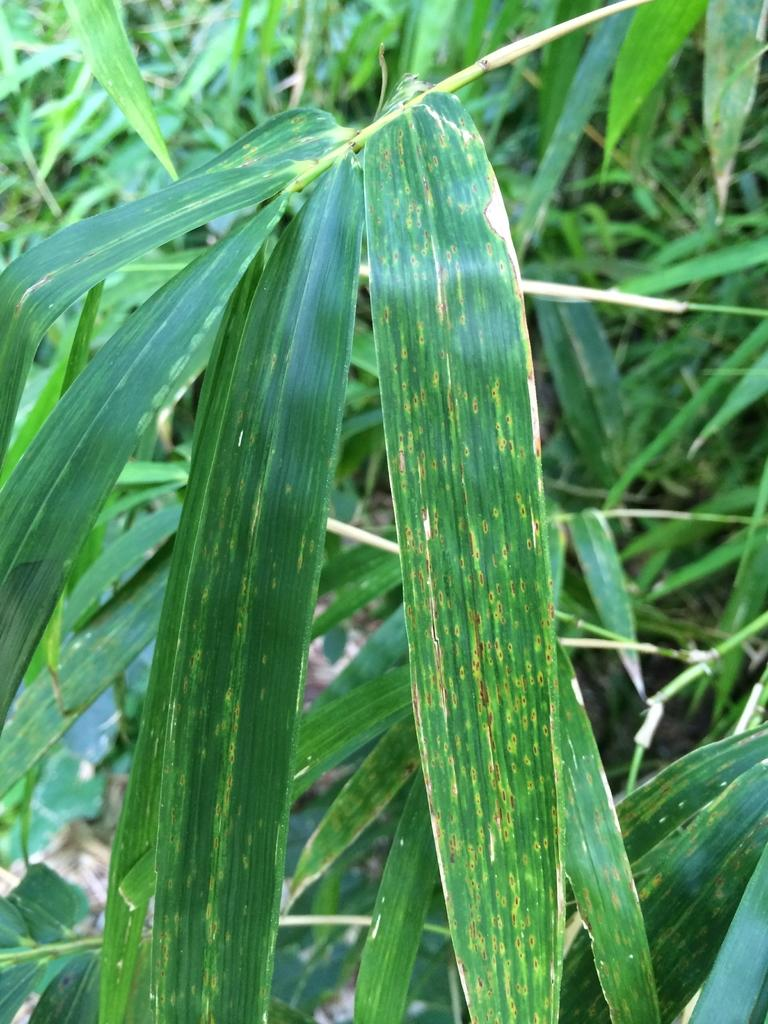What type of living organisms can be seen in the image? Plants can be seen in the image. What is the color of the plants in the image? The plants are green in color. What type of music can be heard coming from the plants in the image? There is no music present in the image, as plants do not produce or play music. 